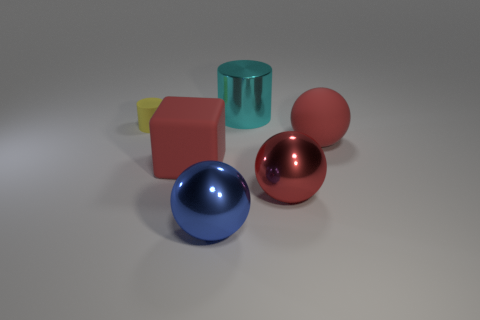Add 1 small gray cylinders. How many objects exist? 7 Subtract all cubes. How many objects are left? 5 Subtract all brown objects. Subtract all red things. How many objects are left? 3 Add 5 large red balls. How many large red balls are left? 7 Add 4 large cyan matte cylinders. How many large cyan matte cylinders exist? 4 Subtract 0 brown cubes. How many objects are left? 6 